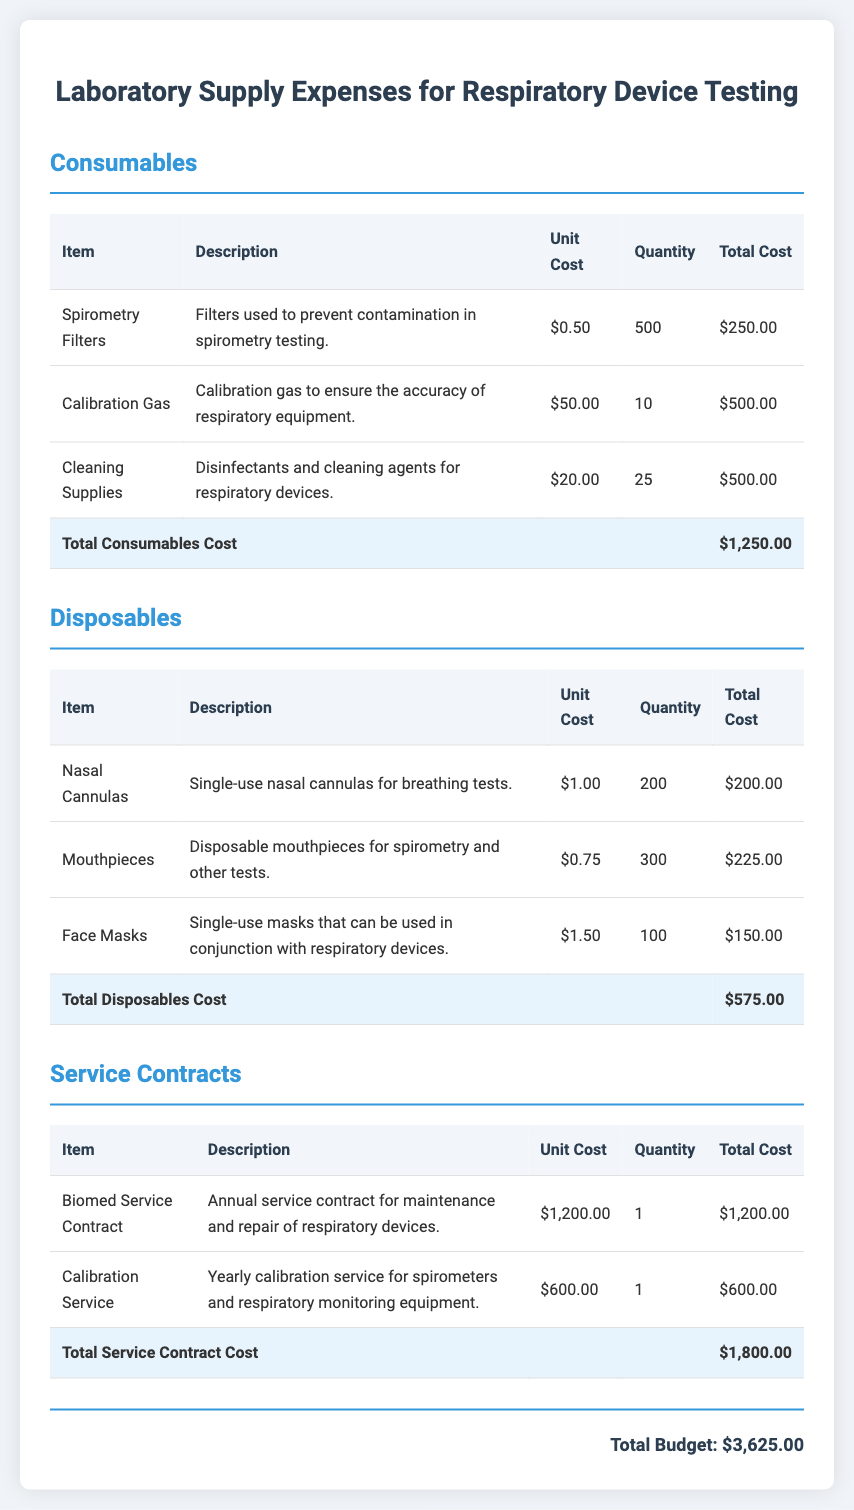What is the total cost of consumables? The total cost of consumables is listed at the bottom of the consumables table, which totals $1,250.00.
Answer: $1,250.00 How many Nasal Cannulas are included? The total quantity of Nasal Cannulas is found in the disposables table, which states there are 200.
Answer: 200 What is the unit cost of Calibration Gas? The unit cost of Calibration Gas is mentioned in the consumables table as $50.00.
Answer: $50.00 What is the total budget? The total budget is presented in the grand total section of the document, which amounts to $3,625.00.
Answer: $3,625.00 What item requires an annual service contract? The item that requires an annual service contract is the Biomed Service Contract, as listed in the service contracts section.
Answer: Biomed Service Contract What is the cost of the Calibration Service? The cost of the Calibration Service is indicated in the service contracts table as $600.00.
Answer: $600.00 How many Mouthpieces are included? The total quantity of Mouthpieces can be found in the disposables section, which states there are 300.
Answer: 300 What is the total cost of disposables? The total cost of disposables is shown at the bottom of the disposables table, which amounts to $575.00.
Answer: $575.00 What type of device is mentioned for maintenance in the service contract? The type of device mentioned for maintenance is respiratory devices according to the description under service contracts.
Answer: respiratory devices 